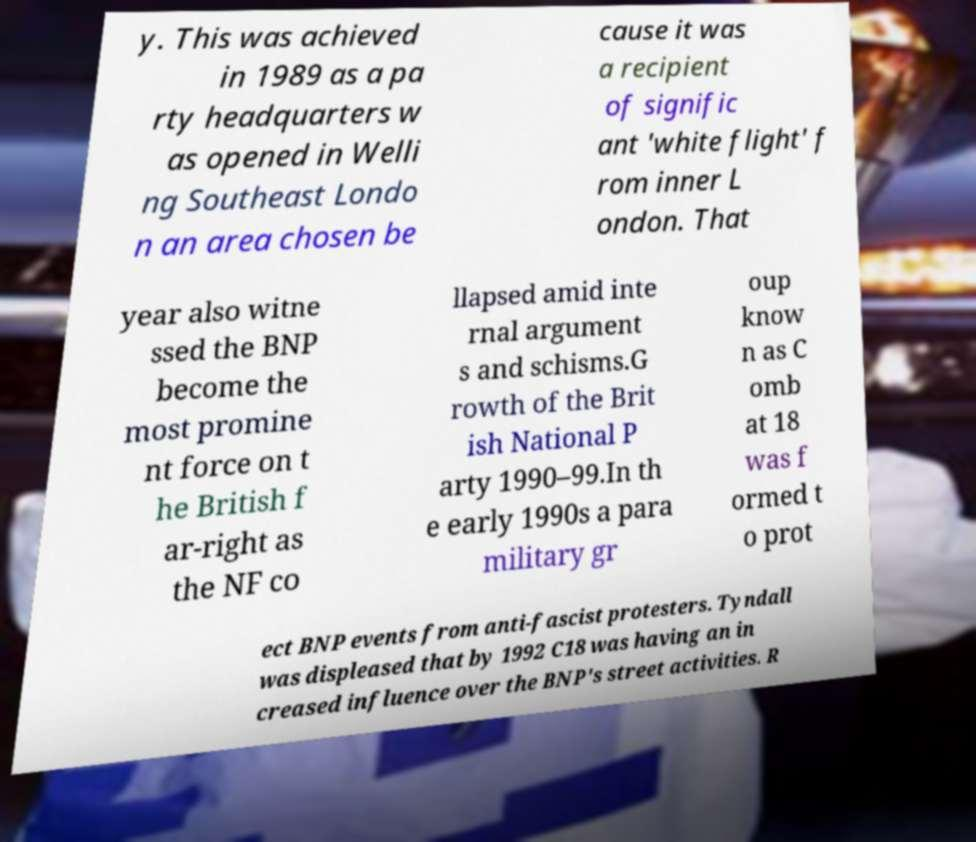For documentation purposes, I need the text within this image transcribed. Could you provide that? y. This was achieved in 1989 as a pa rty headquarters w as opened in Welli ng Southeast Londo n an area chosen be cause it was a recipient of signific ant 'white flight' f rom inner L ondon. That year also witne ssed the BNP become the most promine nt force on t he British f ar-right as the NF co llapsed amid inte rnal argument s and schisms.G rowth of the Brit ish National P arty 1990–99.In th e early 1990s a para military gr oup know n as C omb at 18 was f ormed t o prot ect BNP events from anti-fascist protesters. Tyndall was displeased that by 1992 C18 was having an in creased influence over the BNP's street activities. R 